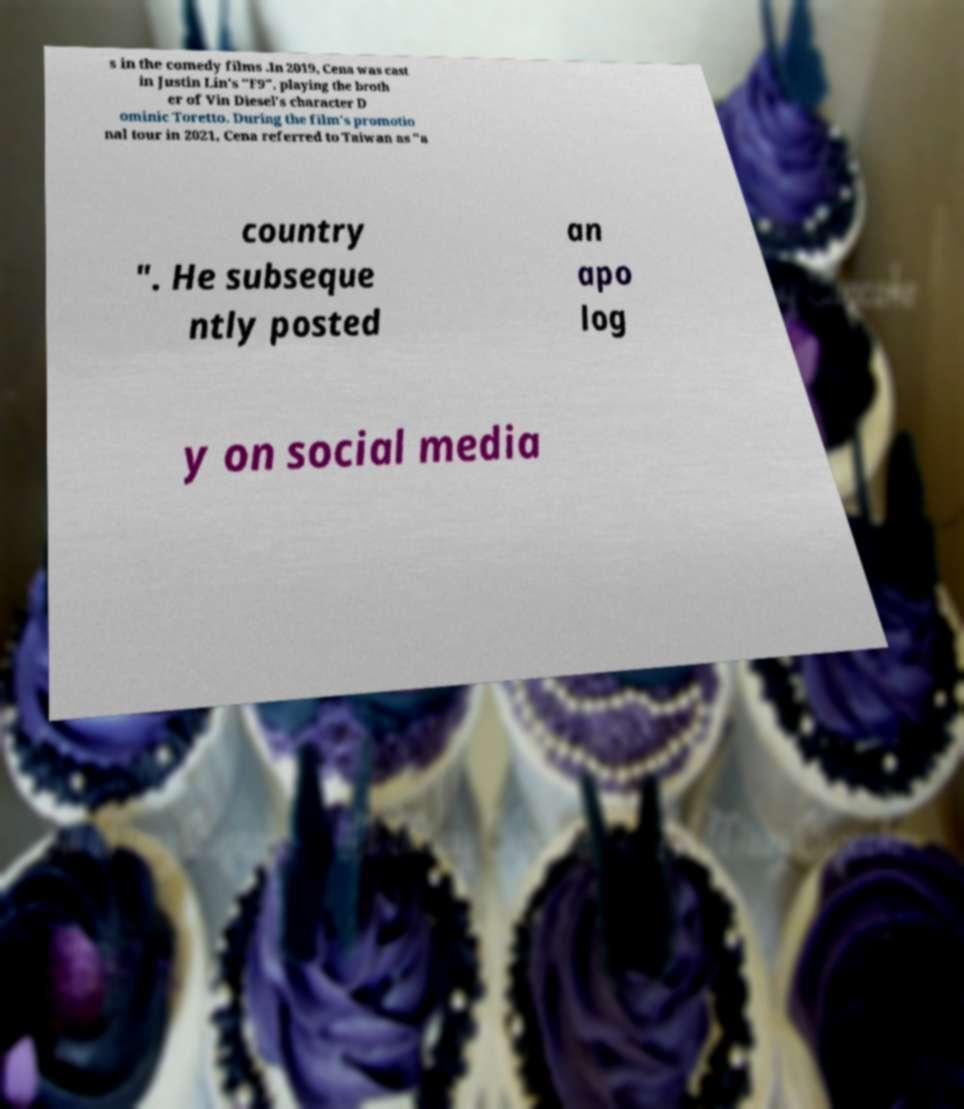Could you assist in decoding the text presented in this image and type it out clearly? s in the comedy films .In 2019, Cena was cast in Justin Lin's "F9", playing the broth er of Vin Diesel's character D ominic Toretto. During the film's promotio nal tour in 2021, Cena referred to Taiwan as "a country ". He subseque ntly posted an apo log y on social media 